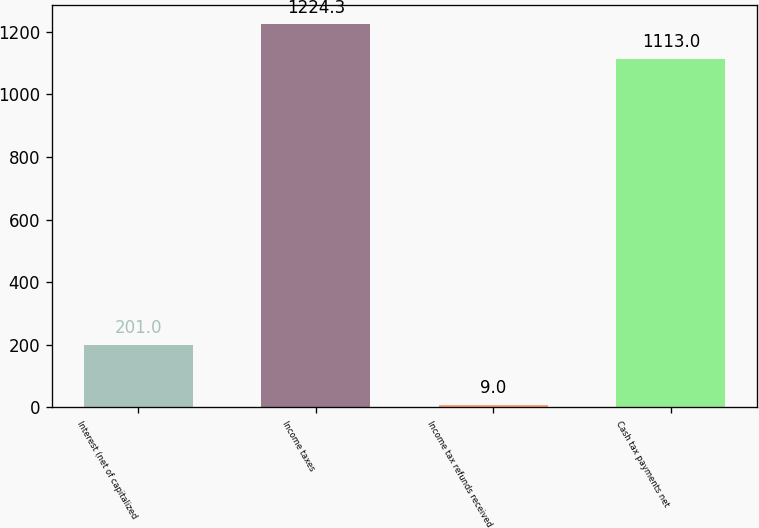<chart> <loc_0><loc_0><loc_500><loc_500><bar_chart><fcel>Interest (net of capitalized<fcel>Income taxes<fcel>Income tax refunds received<fcel>Cash tax payments net<nl><fcel>201<fcel>1224.3<fcel>9<fcel>1113<nl></chart> 